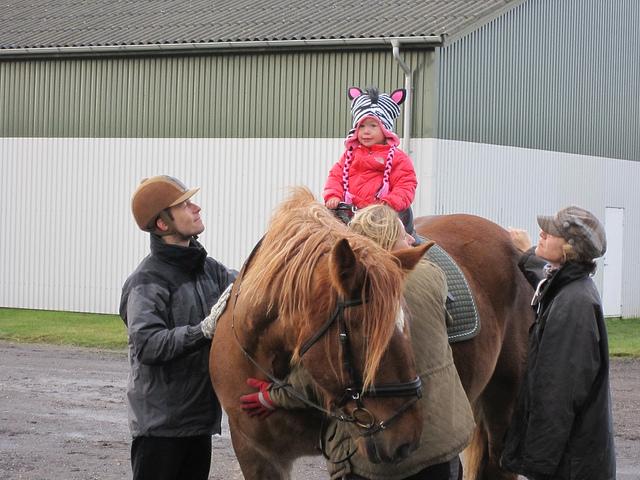What color is the child's skirt?
Concise answer only. Pink. What kind of hat is the child wearing?
Concise answer only. Zebra. What sport is this?
Write a very short answer. Horseback riding. Is she a professional jockey?
Quick response, please. No. What color is the guy's hat?
Be succinct. Brown. Does the child have a hair accessory?
Short answer required. Yes. What is the person in black doing?
Concise answer only. Watching. What animal is this?
Answer briefly. Horse. How many kids are there?
Keep it brief. 1. 